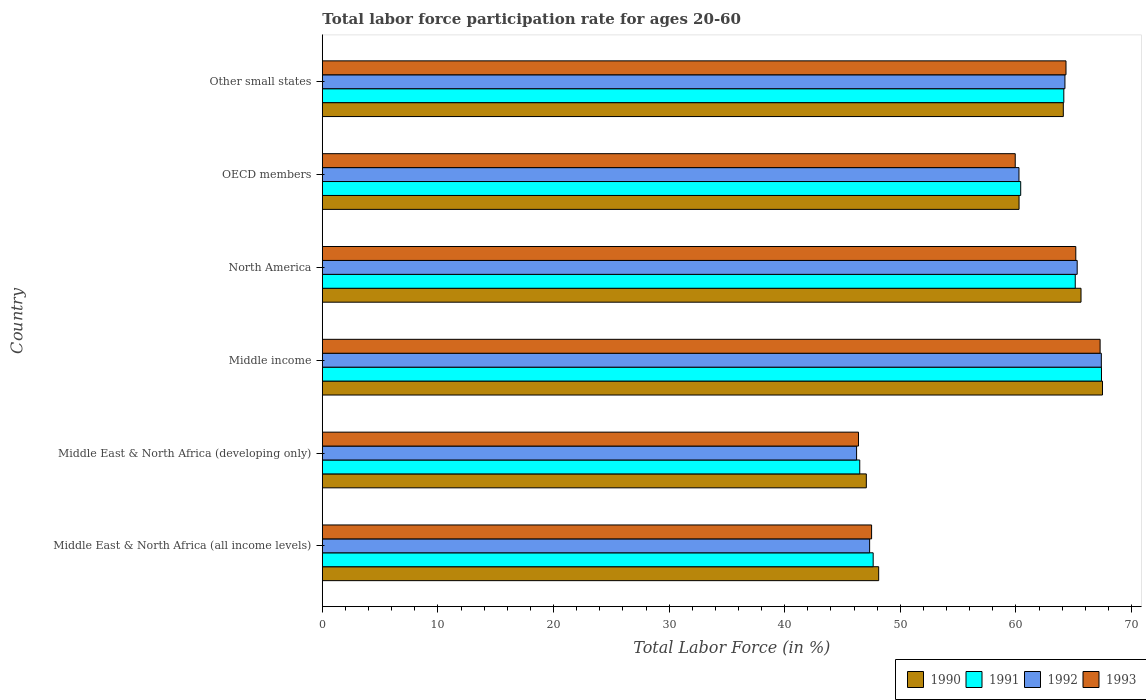How many bars are there on the 3rd tick from the bottom?
Ensure brevity in your answer.  4. What is the labor force participation rate in 1992 in Middle income?
Your response must be concise. 67.39. Across all countries, what is the maximum labor force participation rate in 1993?
Keep it short and to the point. 67.28. Across all countries, what is the minimum labor force participation rate in 1990?
Make the answer very short. 47.06. In which country was the labor force participation rate in 1993 maximum?
Provide a short and direct response. Middle income. In which country was the labor force participation rate in 1992 minimum?
Provide a succinct answer. Middle East & North Africa (developing only). What is the total labor force participation rate in 1993 in the graph?
Your response must be concise. 350.63. What is the difference between the labor force participation rate in 1993 in Middle East & North Africa (developing only) and that in OECD members?
Give a very brief answer. -13.56. What is the difference between the labor force participation rate in 1991 in OECD members and the labor force participation rate in 1990 in North America?
Ensure brevity in your answer.  -5.22. What is the average labor force participation rate in 1992 per country?
Your answer should be compact. 58.46. What is the difference between the labor force participation rate in 1992 and labor force participation rate in 1990 in North America?
Your answer should be very brief. -0.33. What is the ratio of the labor force participation rate in 1993 in Middle East & North Africa (developing only) to that in Middle income?
Give a very brief answer. 0.69. Is the difference between the labor force participation rate in 1992 in OECD members and Other small states greater than the difference between the labor force participation rate in 1990 in OECD members and Other small states?
Provide a short and direct response. No. What is the difference between the highest and the second highest labor force participation rate in 1990?
Keep it short and to the point. 1.86. What is the difference between the highest and the lowest labor force participation rate in 1992?
Provide a succinct answer. 21.17. In how many countries, is the labor force participation rate in 1990 greater than the average labor force participation rate in 1990 taken over all countries?
Ensure brevity in your answer.  4. What does the 4th bar from the bottom in Middle East & North Africa (all income levels) represents?
Make the answer very short. 1993. Is it the case that in every country, the sum of the labor force participation rate in 1993 and labor force participation rate in 1990 is greater than the labor force participation rate in 1991?
Make the answer very short. Yes. How many bars are there?
Make the answer very short. 24. Are all the bars in the graph horizontal?
Your answer should be compact. Yes. Are the values on the major ticks of X-axis written in scientific E-notation?
Provide a short and direct response. No. Where does the legend appear in the graph?
Your answer should be very brief. Bottom right. How are the legend labels stacked?
Your answer should be compact. Horizontal. What is the title of the graph?
Make the answer very short. Total labor force participation rate for ages 20-60. What is the label or title of the Y-axis?
Offer a very short reply. Country. What is the Total Labor Force (in %) of 1990 in Middle East & North Africa (all income levels)?
Keep it short and to the point. 48.13. What is the Total Labor Force (in %) in 1991 in Middle East & North Africa (all income levels)?
Provide a succinct answer. 47.65. What is the Total Labor Force (in %) in 1992 in Middle East & North Africa (all income levels)?
Offer a terse response. 47.34. What is the Total Labor Force (in %) of 1993 in Middle East & North Africa (all income levels)?
Your response must be concise. 47.51. What is the Total Labor Force (in %) in 1990 in Middle East & North Africa (developing only)?
Your response must be concise. 47.06. What is the Total Labor Force (in %) of 1991 in Middle East & North Africa (developing only)?
Give a very brief answer. 46.49. What is the Total Labor Force (in %) in 1992 in Middle East & North Africa (developing only)?
Give a very brief answer. 46.22. What is the Total Labor Force (in %) of 1993 in Middle East & North Africa (developing only)?
Your answer should be very brief. 46.38. What is the Total Labor Force (in %) of 1990 in Middle income?
Your response must be concise. 67.49. What is the Total Labor Force (in %) in 1991 in Middle income?
Provide a short and direct response. 67.4. What is the Total Labor Force (in %) of 1992 in Middle income?
Ensure brevity in your answer.  67.39. What is the Total Labor Force (in %) of 1993 in Middle income?
Keep it short and to the point. 67.28. What is the Total Labor Force (in %) of 1990 in North America?
Provide a succinct answer. 65.63. What is the Total Labor Force (in %) of 1991 in North America?
Your answer should be compact. 65.13. What is the Total Labor Force (in %) of 1992 in North America?
Provide a short and direct response. 65.3. What is the Total Labor Force (in %) of 1993 in North America?
Offer a terse response. 65.18. What is the Total Labor Force (in %) of 1990 in OECD members?
Provide a succinct answer. 60.27. What is the Total Labor Force (in %) of 1991 in OECD members?
Your answer should be compact. 60.41. What is the Total Labor Force (in %) of 1992 in OECD members?
Your answer should be compact. 60.26. What is the Total Labor Force (in %) in 1993 in OECD members?
Keep it short and to the point. 59.94. What is the Total Labor Force (in %) in 1990 in Other small states?
Make the answer very short. 64.1. What is the Total Labor Force (in %) in 1991 in Other small states?
Your response must be concise. 64.14. What is the Total Labor Force (in %) of 1992 in Other small states?
Keep it short and to the point. 64.24. What is the Total Labor Force (in %) of 1993 in Other small states?
Provide a succinct answer. 64.33. Across all countries, what is the maximum Total Labor Force (in %) of 1990?
Offer a terse response. 67.49. Across all countries, what is the maximum Total Labor Force (in %) of 1991?
Provide a succinct answer. 67.4. Across all countries, what is the maximum Total Labor Force (in %) in 1992?
Your response must be concise. 67.39. Across all countries, what is the maximum Total Labor Force (in %) in 1993?
Offer a terse response. 67.28. Across all countries, what is the minimum Total Labor Force (in %) in 1990?
Give a very brief answer. 47.06. Across all countries, what is the minimum Total Labor Force (in %) of 1991?
Your answer should be compact. 46.49. Across all countries, what is the minimum Total Labor Force (in %) of 1992?
Keep it short and to the point. 46.22. Across all countries, what is the minimum Total Labor Force (in %) in 1993?
Offer a very short reply. 46.38. What is the total Total Labor Force (in %) of 1990 in the graph?
Your answer should be compact. 352.67. What is the total Total Labor Force (in %) of 1991 in the graph?
Keep it short and to the point. 351.23. What is the total Total Labor Force (in %) in 1992 in the graph?
Keep it short and to the point. 350.75. What is the total Total Labor Force (in %) of 1993 in the graph?
Provide a succinct answer. 350.63. What is the difference between the Total Labor Force (in %) of 1990 in Middle East & North Africa (all income levels) and that in Middle East & North Africa (developing only)?
Give a very brief answer. 1.07. What is the difference between the Total Labor Force (in %) of 1991 in Middle East & North Africa (all income levels) and that in Middle East & North Africa (developing only)?
Make the answer very short. 1.16. What is the difference between the Total Labor Force (in %) of 1992 in Middle East & North Africa (all income levels) and that in Middle East & North Africa (developing only)?
Your response must be concise. 1.13. What is the difference between the Total Labor Force (in %) in 1993 in Middle East & North Africa (all income levels) and that in Middle East & North Africa (developing only)?
Make the answer very short. 1.13. What is the difference between the Total Labor Force (in %) in 1990 in Middle East & North Africa (all income levels) and that in Middle income?
Make the answer very short. -19.36. What is the difference between the Total Labor Force (in %) in 1991 in Middle East & North Africa (all income levels) and that in Middle income?
Provide a short and direct response. -19.75. What is the difference between the Total Labor Force (in %) in 1992 in Middle East & North Africa (all income levels) and that in Middle income?
Your response must be concise. -20.04. What is the difference between the Total Labor Force (in %) in 1993 in Middle East & North Africa (all income levels) and that in Middle income?
Your response must be concise. -19.77. What is the difference between the Total Labor Force (in %) of 1990 in Middle East & North Africa (all income levels) and that in North America?
Your answer should be compact. -17.51. What is the difference between the Total Labor Force (in %) of 1991 in Middle East & North Africa (all income levels) and that in North America?
Make the answer very short. -17.48. What is the difference between the Total Labor Force (in %) in 1992 in Middle East & North Africa (all income levels) and that in North America?
Offer a terse response. -17.96. What is the difference between the Total Labor Force (in %) of 1993 in Middle East & North Africa (all income levels) and that in North America?
Your answer should be compact. -17.66. What is the difference between the Total Labor Force (in %) in 1990 in Middle East & North Africa (all income levels) and that in OECD members?
Provide a short and direct response. -12.14. What is the difference between the Total Labor Force (in %) in 1991 in Middle East & North Africa (all income levels) and that in OECD members?
Make the answer very short. -12.76. What is the difference between the Total Labor Force (in %) in 1992 in Middle East & North Africa (all income levels) and that in OECD members?
Keep it short and to the point. -12.92. What is the difference between the Total Labor Force (in %) of 1993 in Middle East & North Africa (all income levels) and that in OECD members?
Ensure brevity in your answer.  -12.43. What is the difference between the Total Labor Force (in %) in 1990 in Middle East & North Africa (all income levels) and that in Other small states?
Your response must be concise. -15.97. What is the difference between the Total Labor Force (in %) in 1991 in Middle East & North Africa (all income levels) and that in Other small states?
Offer a very short reply. -16.49. What is the difference between the Total Labor Force (in %) in 1992 in Middle East & North Africa (all income levels) and that in Other small states?
Your response must be concise. -16.9. What is the difference between the Total Labor Force (in %) in 1993 in Middle East & North Africa (all income levels) and that in Other small states?
Make the answer very short. -16.82. What is the difference between the Total Labor Force (in %) in 1990 in Middle East & North Africa (developing only) and that in Middle income?
Your answer should be very brief. -20.43. What is the difference between the Total Labor Force (in %) of 1991 in Middle East & North Africa (developing only) and that in Middle income?
Ensure brevity in your answer.  -20.91. What is the difference between the Total Labor Force (in %) of 1992 in Middle East & North Africa (developing only) and that in Middle income?
Ensure brevity in your answer.  -21.17. What is the difference between the Total Labor Force (in %) in 1993 in Middle East & North Africa (developing only) and that in Middle income?
Provide a succinct answer. -20.9. What is the difference between the Total Labor Force (in %) of 1990 in Middle East & North Africa (developing only) and that in North America?
Your answer should be compact. -18.57. What is the difference between the Total Labor Force (in %) in 1991 in Middle East & North Africa (developing only) and that in North America?
Give a very brief answer. -18.64. What is the difference between the Total Labor Force (in %) of 1992 in Middle East & North Africa (developing only) and that in North America?
Offer a very short reply. -19.08. What is the difference between the Total Labor Force (in %) of 1993 in Middle East & North Africa (developing only) and that in North America?
Keep it short and to the point. -18.8. What is the difference between the Total Labor Force (in %) of 1990 in Middle East & North Africa (developing only) and that in OECD members?
Offer a very short reply. -13.21. What is the difference between the Total Labor Force (in %) of 1991 in Middle East & North Africa (developing only) and that in OECD members?
Offer a very short reply. -13.92. What is the difference between the Total Labor Force (in %) in 1992 in Middle East & North Africa (developing only) and that in OECD members?
Your answer should be very brief. -14.05. What is the difference between the Total Labor Force (in %) of 1993 in Middle East & North Africa (developing only) and that in OECD members?
Keep it short and to the point. -13.56. What is the difference between the Total Labor Force (in %) in 1990 in Middle East & North Africa (developing only) and that in Other small states?
Give a very brief answer. -17.04. What is the difference between the Total Labor Force (in %) of 1991 in Middle East & North Africa (developing only) and that in Other small states?
Keep it short and to the point. -17.65. What is the difference between the Total Labor Force (in %) in 1992 in Middle East & North Africa (developing only) and that in Other small states?
Provide a succinct answer. -18.02. What is the difference between the Total Labor Force (in %) in 1993 in Middle East & North Africa (developing only) and that in Other small states?
Your answer should be very brief. -17.95. What is the difference between the Total Labor Force (in %) in 1990 in Middle income and that in North America?
Ensure brevity in your answer.  1.86. What is the difference between the Total Labor Force (in %) of 1991 in Middle income and that in North America?
Offer a very short reply. 2.27. What is the difference between the Total Labor Force (in %) in 1992 in Middle income and that in North America?
Provide a succinct answer. 2.09. What is the difference between the Total Labor Force (in %) of 1993 in Middle income and that in North America?
Offer a very short reply. 2.1. What is the difference between the Total Labor Force (in %) in 1990 in Middle income and that in OECD members?
Ensure brevity in your answer.  7.22. What is the difference between the Total Labor Force (in %) of 1991 in Middle income and that in OECD members?
Your answer should be compact. 6.99. What is the difference between the Total Labor Force (in %) in 1992 in Middle income and that in OECD members?
Your answer should be very brief. 7.12. What is the difference between the Total Labor Force (in %) in 1993 in Middle income and that in OECD members?
Offer a terse response. 7.34. What is the difference between the Total Labor Force (in %) of 1990 in Middle income and that in Other small states?
Provide a succinct answer. 3.39. What is the difference between the Total Labor Force (in %) of 1991 in Middle income and that in Other small states?
Your response must be concise. 3.26. What is the difference between the Total Labor Force (in %) of 1992 in Middle income and that in Other small states?
Offer a terse response. 3.15. What is the difference between the Total Labor Force (in %) of 1993 in Middle income and that in Other small states?
Give a very brief answer. 2.95. What is the difference between the Total Labor Force (in %) of 1990 in North America and that in OECD members?
Provide a short and direct response. 5.36. What is the difference between the Total Labor Force (in %) of 1991 in North America and that in OECD members?
Your response must be concise. 4.72. What is the difference between the Total Labor Force (in %) in 1992 in North America and that in OECD members?
Offer a very short reply. 5.04. What is the difference between the Total Labor Force (in %) of 1993 in North America and that in OECD members?
Your answer should be very brief. 5.24. What is the difference between the Total Labor Force (in %) in 1990 in North America and that in Other small states?
Offer a very short reply. 1.53. What is the difference between the Total Labor Force (in %) of 1991 in North America and that in Other small states?
Provide a succinct answer. 0.99. What is the difference between the Total Labor Force (in %) of 1992 in North America and that in Other small states?
Your answer should be compact. 1.06. What is the difference between the Total Labor Force (in %) in 1993 in North America and that in Other small states?
Your answer should be compact. 0.85. What is the difference between the Total Labor Force (in %) in 1990 in OECD members and that in Other small states?
Keep it short and to the point. -3.83. What is the difference between the Total Labor Force (in %) in 1991 in OECD members and that in Other small states?
Your answer should be compact. -3.73. What is the difference between the Total Labor Force (in %) in 1992 in OECD members and that in Other small states?
Ensure brevity in your answer.  -3.98. What is the difference between the Total Labor Force (in %) of 1993 in OECD members and that in Other small states?
Give a very brief answer. -4.39. What is the difference between the Total Labor Force (in %) in 1990 in Middle East & North Africa (all income levels) and the Total Labor Force (in %) in 1991 in Middle East & North Africa (developing only)?
Ensure brevity in your answer.  1.64. What is the difference between the Total Labor Force (in %) in 1990 in Middle East & North Africa (all income levels) and the Total Labor Force (in %) in 1992 in Middle East & North Africa (developing only)?
Make the answer very short. 1.91. What is the difference between the Total Labor Force (in %) of 1990 in Middle East & North Africa (all income levels) and the Total Labor Force (in %) of 1993 in Middle East & North Africa (developing only)?
Make the answer very short. 1.75. What is the difference between the Total Labor Force (in %) of 1991 in Middle East & North Africa (all income levels) and the Total Labor Force (in %) of 1992 in Middle East & North Africa (developing only)?
Offer a terse response. 1.43. What is the difference between the Total Labor Force (in %) of 1991 in Middle East & North Africa (all income levels) and the Total Labor Force (in %) of 1993 in Middle East & North Africa (developing only)?
Your response must be concise. 1.27. What is the difference between the Total Labor Force (in %) in 1992 in Middle East & North Africa (all income levels) and the Total Labor Force (in %) in 1993 in Middle East & North Africa (developing only)?
Give a very brief answer. 0.96. What is the difference between the Total Labor Force (in %) of 1990 in Middle East & North Africa (all income levels) and the Total Labor Force (in %) of 1991 in Middle income?
Give a very brief answer. -19.28. What is the difference between the Total Labor Force (in %) in 1990 in Middle East & North Africa (all income levels) and the Total Labor Force (in %) in 1992 in Middle income?
Make the answer very short. -19.26. What is the difference between the Total Labor Force (in %) of 1990 in Middle East & North Africa (all income levels) and the Total Labor Force (in %) of 1993 in Middle income?
Provide a short and direct response. -19.16. What is the difference between the Total Labor Force (in %) of 1991 in Middle East & North Africa (all income levels) and the Total Labor Force (in %) of 1992 in Middle income?
Offer a very short reply. -19.74. What is the difference between the Total Labor Force (in %) in 1991 in Middle East & North Africa (all income levels) and the Total Labor Force (in %) in 1993 in Middle income?
Your answer should be very brief. -19.63. What is the difference between the Total Labor Force (in %) of 1992 in Middle East & North Africa (all income levels) and the Total Labor Force (in %) of 1993 in Middle income?
Ensure brevity in your answer.  -19.94. What is the difference between the Total Labor Force (in %) in 1990 in Middle East & North Africa (all income levels) and the Total Labor Force (in %) in 1991 in North America?
Keep it short and to the point. -17.01. What is the difference between the Total Labor Force (in %) of 1990 in Middle East & North Africa (all income levels) and the Total Labor Force (in %) of 1992 in North America?
Make the answer very short. -17.17. What is the difference between the Total Labor Force (in %) in 1990 in Middle East & North Africa (all income levels) and the Total Labor Force (in %) in 1993 in North America?
Make the answer very short. -17.05. What is the difference between the Total Labor Force (in %) in 1991 in Middle East & North Africa (all income levels) and the Total Labor Force (in %) in 1992 in North America?
Keep it short and to the point. -17.65. What is the difference between the Total Labor Force (in %) of 1991 in Middle East & North Africa (all income levels) and the Total Labor Force (in %) of 1993 in North America?
Offer a very short reply. -17.53. What is the difference between the Total Labor Force (in %) of 1992 in Middle East & North Africa (all income levels) and the Total Labor Force (in %) of 1993 in North America?
Your answer should be compact. -17.84. What is the difference between the Total Labor Force (in %) of 1990 in Middle East & North Africa (all income levels) and the Total Labor Force (in %) of 1991 in OECD members?
Offer a terse response. -12.29. What is the difference between the Total Labor Force (in %) in 1990 in Middle East & North Africa (all income levels) and the Total Labor Force (in %) in 1992 in OECD members?
Your answer should be compact. -12.14. What is the difference between the Total Labor Force (in %) of 1990 in Middle East & North Africa (all income levels) and the Total Labor Force (in %) of 1993 in OECD members?
Provide a succinct answer. -11.81. What is the difference between the Total Labor Force (in %) of 1991 in Middle East & North Africa (all income levels) and the Total Labor Force (in %) of 1992 in OECD members?
Keep it short and to the point. -12.61. What is the difference between the Total Labor Force (in %) in 1991 in Middle East & North Africa (all income levels) and the Total Labor Force (in %) in 1993 in OECD members?
Your response must be concise. -12.29. What is the difference between the Total Labor Force (in %) in 1992 in Middle East & North Africa (all income levels) and the Total Labor Force (in %) in 1993 in OECD members?
Offer a very short reply. -12.6. What is the difference between the Total Labor Force (in %) in 1990 in Middle East & North Africa (all income levels) and the Total Labor Force (in %) in 1991 in Other small states?
Your answer should be very brief. -16.02. What is the difference between the Total Labor Force (in %) of 1990 in Middle East & North Africa (all income levels) and the Total Labor Force (in %) of 1992 in Other small states?
Make the answer very short. -16.11. What is the difference between the Total Labor Force (in %) of 1990 in Middle East & North Africa (all income levels) and the Total Labor Force (in %) of 1993 in Other small states?
Your answer should be compact. -16.21. What is the difference between the Total Labor Force (in %) of 1991 in Middle East & North Africa (all income levels) and the Total Labor Force (in %) of 1992 in Other small states?
Provide a succinct answer. -16.59. What is the difference between the Total Labor Force (in %) in 1991 in Middle East & North Africa (all income levels) and the Total Labor Force (in %) in 1993 in Other small states?
Provide a succinct answer. -16.68. What is the difference between the Total Labor Force (in %) of 1992 in Middle East & North Africa (all income levels) and the Total Labor Force (in %) of 1993 in Other small states?
Make the answer very short. -16.99. What is the difference between the Total Labor Force (in %) of 1990 in Middle East & North Africa (developing only) and the Total Labor Force (in %) of 1991 in Middle income?
Offer a terse response. -20.34. What is the difference between the Total Labor Force (in %) of 1990 in Middle East & North Africa (developing only) and the Total Labor Force (in %) of 1992 in Middle income?
Offer a very short reply. -20.33. What is the difference between the Total Labor Force (in %) of 1990 in Middle East & North Africa (developing only) and the Total Labor Force (in %) of 1993 in Middle income?
Provide a succinct answer. -20.22. What is the difference between the Total Labor Force (in %) in 1991 in Middle East & North Africa (developing only) and the Total Labor Force (in %) in 1992 in Middle income?
Offer a terse response. -20.9. What is the difference between the Total Labor Force (in %) in 1991 in Middle East & North Africa (developing only) and the Total Labor Force (in %) in 1993 in Middle income?
Provide a succinct answer. -20.79. What is the difference between the Total Labor Force (in %) in 1992 in Middle East & North Africa (developing only) and the Total Labor Force (in %) in 1993 in Middle income?
Offer a terse response. -21.07. What is the difference between the Total Labor Force (in %) of 1990 in Middle East & North Africa (developing only) and the Total Labor Force (in %) of 1991 in North America?
Offer a terse response. -18.07. What is the difference between the Total Labor Force (in %) in 1990 in Middle East & North Africa (developing only) and the Total Labor Force (in %) in 1992 in North America?
Provide a succinct answer. -18.24. What is the difference between the Total Labor Force (in %) in 1990 in Middle East & North Africa (developing only) and the Total Labor Force (in %) in 1993 in North America?
Offer a very short reply. -18.12. What is the difference between the Total Labor Force (in %) in 1991 in Middle East & North Africa (developing only) and the Total Labor Force (in %) in 1992 in North America?
Provide a short and direct response. -18.81. What is the difference between the Total Labor Force (in %) of 1991 in Middle East & North Africa (developing only) and the Total Labor Force (in %) of 1993 in North America?
Ensure brevity in your answer.  -18.69. What is the difference between the Total Labor Force (in %) in 1992 in Middle East & North Africa (developing only) and the Total Labor Force (in %) in 1993 in North America?
Make the answer very short. -18.96. What is the difference between the Total Labor Force (in %) of 1990 in Middle East & North Africa (developing only) and the Total Labor Force (in %) of 1991 in OECD members?
Your answer should be compact. -13.35. What is the difference between the Total Labor Force (in %) in 1990 in Middle East & North Africa (developing only) and the Total Labor Force (in %) in 1992 in OECD members?
Offer a terse response. -13.21. What is the difference between the Total Labor Force (in %) of 1990 in Middle East & North Africa (developing only) and the Total Labor Force (in %) of 1993 in OECD members?
Keep it short and to the point. -12.88. What is the difference between the Total Labor Force (in %) in 1991 in Middle East & North Africa (developing only) and the Total Labor Force (in %) in 1992 in OECD members?
Ensure brevity in your answer.  -13.77. What is the difference between the Total Labor Force (in %) of 1991 in Middle East & North Africa (developing only) and the Total Labor Force (in %) of 1993 in OECD members?
Ensure brevity in your answer.  -13.45. What is the difference between the Total Labor Force (in %) of 1992 in Middle East & North Africa (developing only) and the Total Labor Force (in %) of 1993 in OECD members?
Your answer should be very brief. -13.72. What is the difference between the Total Labor Force (in %) in 1990 in Middle East & North Africa (developing only) and the Total Labor Force (in %) in 1991 in Other small states?
Make the answer very short. -17.08. What is the difference between the Total Labor Force (in %) of 1990 in Middle East & North Africa (developing only) and the Total Labor Force (in %) of 1992 in Other small states?
Your answer should be compact. -17.18. What is the difference between the Total Labor Force (in %) in 1990 in Middle East & North Africa (developing only) and the Total Labor Force (in %) in 1993 in Other small states?
Offer a very short reply. -17.27. What is the difference between the Total Labor Force (in %) of 1991 in Middle East & North Africa (developing only) and the Total Labor Force (in %) of 1992 in Other small states?
Your answer should be very brief. -17.75. What is the difference between the Total Labor Force (in %) in 1991 in Middle East & North Africa (developing only) and the Total Labor Force (in %) in 1993 in Other small states?
Your answer should be very brief. -17.84. What is the difference between the Total Labor Force (in %) of 1992 in Middle East & North Africa (developing only) and the Total Labor Force (in %) of 1993 in Other small states?
Offer a terse response. -18.11. What is the difference between the Total Labor Force (in %) in 1990 in Middle income and the Total Labor Force (in %) in 1991 in North America?
Offer a very short reply. 2.36. What is the difference between the Total Labor Force (in %) of 1990 in Middle income and the Total Labor Force (in %) of 1992 in North America?
Your response must be concise. 2.19. What is the difference between the Total Labor Force (in %) of 1990 in Middle income and the Total Labor Force (in %) of 1993 in North America?
Give a very brief answer. 2.31. What is the difference between the Total Labor Force (in %) of 1991 in Middle income and the Total Labor Force (in %) of 1992 in North America?
Your response must be concise. 2.1. What is the difference between the Total Labor Force (in %) of 1991 in Middle income and the Total Labor Force (in %) of 1993 in North America?
Give a very brief answer. 2.22. What is the difference between the Total Labor Force (in %) in 1992 in Middle income and the Total Labor Force (in %) in 1993 in North America?
Give a very brief answer. 2.21. What is the difference between the Total Labor Force (in %) in 1990 in Middle income and the Total Labor Force (in %) in 1991 in OECD members?
Give a very brief answer. 7.07. What is the difference between the Total Labor Force (in %) of 1990 in Middle income and the Total Labor Force (in %) of 1992 in OECD members?
Offer a very short reply. 7.22. What is the difference between the Total Labor Force (in %) of 1990 in Middle income and the Total Labor Force (in %) of 1993 in OECD members?
Offer a very short reply. 7.55. What is the difference between the Total Labor Force (in %) of 1991 in Middle income and the Total Labor Force (in %) of 1992 in OECD members?
Make the answer very short. 7.14. What is the difference between the Total Labor Force (in %) of 1991 in Middle income and the Total Labor Force (in %) of 1993 in OECD members?
Provide a short and direct response. 7.46. What is the difference between the Total Labor Force (in %) in 1992 in Middle income and the Total Labor Force (in %) in 1993 in OECD members?
Provide a short and direct response. 7.45. What is the difference between the Total Labor Force (in %) in 1990 in Middle income and the Total Labor Force (in %) in 1991 in Other small states?
Keep it short and to the point. 3.34. What is the difference between the Total Labor Force (in %) in 1990 in Middle income and the Total Labor Force (in %) in 1992 in Other small states?
Ensure brevity in your answer.  3.25. What is the difference between the Total Labor Force (in %) of 1990 in Middle income and the Total Labor Force (in %) of 1993 in Other small states?
Make the answer very short. 3.16. What is the difference between the Total Labor Force (in %) of 1991 in Middle income and the Total Labor Force (in %) of 1992 in Other small states?
Offer a very short reply. 3.16. What is the difference between the Total Labor Force (in %) of 1991 in Middle income and the Total Labor Force (in %) of 1993 in Other small states?
Provide a short and direct response. 3.07. What is the difference between the Total Labor Force (in %) of 1992 in Middle income and the Total Labor Force (in %) of 1993 in Other small states?
Ensure brevity in your answer.  3.06. What is the difference between the Total Labor Force (in %) in 1990 in North America and the Total Labor Force (in %) in 1991 in OECD members?
Offer a terse response. 5.22. What is the difference between the Total Labor Force (in %) in 1990 in North America and the Total Labor Force (in %) in 1992 in OECD members?
Offer a terse response. 5.37. What is the difference between the Total Labor Force (in %) in 1990 in North America and the Total Labor Force (in %) in 1993 in OECD members?
Ensure brevity in your answer.  5.69. What is the difference between the Total Labor Force (in %) of 1991 in North America and the Total Labor Force (in %) of 1992 in OECD members?
Offer a terse response. 4.87. What is the difference between the Total Labor Force (in %) of 1991 in North America and the Total Labor Force (in %) of 1993 in OECD members?
Your answer should be very brief. 5.19. What is the difference between the Total Labor Force (in %) of 1992 in North America and the Total Labor Force (in %) of 1993 in OECD members?
Provide a short and direct response. 5.36. What is the difference between the Total Labor Force (in %) in 1990 in North America and the Total Labor Force (in %) in 1991 in Other small states?
Make the answer very short. 1.49. What is the difference between the Total Labor Force (in %) in 1990 in North America and the Total Labor Force (in %) in 1992 in Other small states?
Keep it short and to the point. 1.39. What is the difference between the Total Labor Force (in %) in 1990 in North America and the Total Labor Force (in %) in 1993 in Other small states?
Your answer should be compact. 1.3. What is the difference between the Total Labor Force (in %) in 1991 in North America and the Total Labor Force (in %) in 1992 in Other small states?
Your response must be concise. 0.89. What is the difference between the Total Labor Force (in %) of 1991 in North America and the Total Labor Force (in %) of 1993 in Other small states?
Ensure brevity in your answer.  0.8. What is the difference between the Total Labor Force (in %) in 1992 in North America and the Total Labor Force (in %) in 1993 in Other small states?
Provide a succinct answer. 0.97. What is the difference between the Total Labor Force (in %) in 1990 in OECD members and the Total Labor Force (in %) in 1991 in Other small states?
Make the answer very short. -3.87. What is the difference between the Total Labor Force (in %) of 1990 in OECD members and the Total Labor Force (in %) of 1992 in Other small states?
Your answer should be very brief. -3.97. What is the difference between the Total Labor Force (in %) of 1990 in OECD members and the Total Labor Force (in %) of 1993 in Other small states?
Keep it short and to the point. -4.06. What is the difference between the Total Labor Force (in %) in 1991 in OECD members and the Total Labor Force (in %) in 1992 in Other small states?
Make the answer very short. -3.83. What is the difference between the Total Labor Force (in %) of 1991 in OECD members and the Total Labor Force (in %) of 1993 in Other small states?
Your answer should be very brief. -3.92. What is the difference between the Total Labor Force (in %) in 1992 in OECD members and the Total Labor Force (in %) in 1993 in Other small states?
Your answer should be very brief. -4.07. What is the average Total Labor Force (in %) of 1990 per country?
Give a very brief answer. 58.78. What is the average Total Labor Force (in %) of 1991 per country?
Offer a very short reply. 58.54. What is the average Total Labor Force (in %) in 1992 per country?
Your response must be concise. 58.46. What is the average Total Labor Force (in %) in 1993 per country?
Offer a very short reply. 58.44. What is the difference between the Total Labor Force (in %) of 1990 and Total Labor Force (in %) of 1991 in Middle East & North Africa (all income levels)?
Provide a succinct answer. 0.48. What is the difference between the Total Labor Force (in %) of 1990 and Total Labor Force (in %) of 1992 in Middle East & North Africa (all income levels)?
Your answer should be very brief. 0.78. What is the difference between the Total Labor Force (in %) of 1990 and Total Labor Force (in %) of 1993 in Middle East & North Africa (all income levels)?
Offer a very short reply. 0.61. What is the difference between the Total Labor Force (in %) of 1991 and Total Labor Force (in %) of 1992 in Middle East & North Africa (all income levels)?
Make the answer very short. 0.31. What is the difference between the Total Labor Force (in %) in 1991 and Total Labor Force (in %) in 1993 in Middle East & North Africa (all income levels)?
Provide a short and direct response. 0.14. What is the difference between the Total Labor Force (in %) in 1992 and Total Labor Force (in %) in 1993 in Middle East & North Africa (all income levels)?
Make the answer very short. -0.17. What is the difference between the Total Labor Force (in %) of 1990 and Total Labor Force (in %) of 1991 in Middle East & North Africa (developing only)?
Provide a succinct answer. 0.57. What is the difference between the Total Labor Force (in %) in 1990 and Total Labor Force (in %) in 1992 in Middle East & North Africa (developing only)?
Offer a terse response. 0.84. What is the difference between the Total Labor Force (in %) in 1990 and Total Labor Force (in %) in 1993 in Middle East & North Africa (developing only)?
Provide a succinct answer. 0.68. What is the difference between the Total Labor Force (in %) in 1991 and Total Labor Force (in %) in 1992 in Middle East & North Africa (developing only)?
Your response must be concise. 0.27. What is the difference between the Total Labor Force (in %) in 1991 and Total Labor Force (in %) in 1993 in Middle East & North Africa (developing only)?
Make the answer very short. 0.11. What is the difference between the Total Labor Force (in %) in 1992 and Total Labor Force (in %) in 1993 in Middle East & North Africa (developing only)?
Your answer should be very brief. -0.16. What is the difference between the Total Labor Force (in %) of 1990 and Total Labor Force (in %) of 1991 in Middle income?
Provide a short and direct response. 0.09. What is the difference between the Total Labor Force (in %) in 1990 and Total Labor Force (in %) in 1992 in Middle income?
Offer a very short reply. 0.1. What is the difference between the Total Labor Force (in %) of 1990 and Total Labor Force (in %) of 1993 in Middle income?
Offer a very short reply. 0.2. What is the difference between the Total Labor Force (in %) in 1991 and Total Labor Force (in %) in 1992 in Middle income?
Your answer should be compact. 0.01. What is the difference between the Total Labor Force (in %) of 1991 and Total Labor Force (in %) of 1993 in Middle income?
Ensure brevity in your answer.  0.12. What is the difference between the Total Labor Force (in %) in 1992 and Total Labor Force (in %) in 1993 in Middle income?
Offer a terse response. 0.1. What is the difference between the Total Labor Force (in %) in 1990 and Total Labor Force (in %) in 1991 in North America?
Make the answer very short. 0.5. What is the difference between the Total Labor Force (in %) of 1990 and Total Labor Force (in %) of 1992 in North America?
Your response must be concise. 0.33. What is the difference between the Total Labor Force (in %) in 1990 and Total Labor Force (in %) in 1993 in North America?
Provide a succinct answer. 0.45. What is the difference between the Total Labor Force (in %) of 1991 and Total Labor Force (in %) of 1992 in North America?
Your answer should be very brief. -0.17. What is the difference between the Total Labor Force (in %) in 1991 and Total Labor Force (in %) in 1993 in North America?
Provide a succinct answer. -0.05. What is the difference between the Total Labor Force (in %) in 1992 and Total Labor Force (in %) in 1993 in North America?
Provide a succinct answer. 0.12. What is the difference between the Total Labor Force (in %) of 1990 and Total Labor Force (in %) of 1991 in OECD members?
Ensure brevity in your answer.  -0.14. What is the difference between the Total Labor Force (in %) in 1990 and Total Labor Force (in %) in 1992 in OECD members?
Provide a succinct answer. 0.01. What is the difference between the Total Labor Force (in %) of 1990 and Total Labor Force (in %) of 1993 in OECD members?
Make the answer very short. 0.33. What is the difference between the Total Labor Force (in %) of 1991 and Total Labor Force (in %) of 1992 in OECD members?
Your response must be concise. 0.15. What is the difference between the Total Labor Force (in %) of 1991 and Total Labor Force (in %) of 1993 in OECD members?
Offer a very short reply. 0.47. What is the difference between the Total Labor Force (in %) of 1992 and Total Labor Force (in %) of 1993 in OECD members?
Your answer should be very brief. 0.32. What is the difference between the Total Labor Force (in %) in 1990 and Total Labor Force (in %) in 1991 in Other small states?
Make the answer very short. -0.04. What is the difference between the Total Labor Force (in %) of 1990 and Total Labor Force (in %) of 1992 in Other small states?
Your answer should be very brief. -0.14. What is the difference between the Total Labor Force (in %) of 1990 and Total Labor Force (in %) of 1993 in Other small states?
Your answer should be compact. -0.23. What is the difference between the Total Labor Force (in %) in 1991 and Total Labor Force (in %) in 1992 in Other small states?
Make the answer very short. -0.1. What is the difference between the Total Labor Force (in %) of 1991 and Total Labor Force (in %) of 1993 in Other small states?
Your answer should be very brief. -0.19. What is the difference between the Total Labor Force (in %) of 1992 and Total Labor Force (in %) of 1993 in Other small states?
Ensure brevity in your answer.  -0.09. What is the ratio of the Total Labor Force (in %) in 1990 in Middle East & North Africa (all income levels) to that in Middle East & North Africa (developing only)?
Provide a succinct answer. 1.02. What is the ratio of the Total Labor Force (in %) in 1992 in Middle East & North Africa (all income levels) to that in Middle East & North Africa (developing only)?
Make the answer very short. 1.02. What is the ratio of the Total Labor Force (in %) of 1993 in Middle East & North Africa (all income levels) to that in Middle East & North Africa (developing only)?
Provide a short and direct response. 1.02. What is the ratio of the Total Labor Force (in %) in 1990 in Middle East & North Africa (all income levels) to that in Middle income?
Provide a short and direct response. 0.71. What is the ratio of the Total Labor Force (in %) in 1991 in Middle East & North Africa (all income levels) to that in Middle income?
Your response must be concise. 0.71. What is the ratio of the Total Labor Force (in %) of 1992 in Middle East & North Africa (all income levels) to that in Middle income?
Ensure brevity in your answer.  0.7. What is the ratio of the Total Labor Force (in %) of 1993 in Middle East & North Africa (all income levels) to that in Middle income?
Offer a terse response. 0.71. What is the ratio of the Total Labor Force (in %) in 1990 in Middle East & North Africa (all income levels) to that in North America?
Keep it short and to the point. 0.73. What is the ratio of the Total Labor Force (in %) of 1991 in Middle East & North Africa (all income levels) to that in North America?
Your answer should be compact. 0.73. What is the ratio of the Total Labor Force (in %) in 1992 in Middle East & North Africa (all income levels) to that in North America?
Ensure brevity in your answer.  0.72. What is the ratio of the Total Labor Force (in %) of 1993 in Middle East & North Africa (all income levels) to that in North America?
Offer a terse response. 0.73. What is the ratio of the Total Labor Force (in %) of 1990 in Middle East & North Africa (all income levels) to that in OECD members?
Make the answer very short. 0.8. What is the ratio of the Total Labor Force (in %) of 1991 in Middle East & North Africa (all income levels) to that in OECD members?
Your answer should be compact. 0.79. What is the ratio of the Total Labor Force (in %) in 1992 in Middle East & North Africa (all income levels) to that in OECD members?
Your response must be concise. 0.79. What is the ratio of the Total Labor Force (in %) of 1993 in Middle East & North Africa (all income levels) to that in OECD members?
Make the answer very short. 0.79. What is the ratio of the Total Labor Force (in %) in 1990 in Middle East & North Africa (all income levels) to that in Other small states?
Provide a short and direct response. 0.75. What is the ratio of the Total Labor Force (in %) of 1991 in Middle East & North Africa (all income levels) to that in Other small states?
Your response must be concise. 0.74. What is the ratio of the Total Labor Force (in %) in 1992 in Middle East & North Africa (all income levels) to that in Other small states?
Give a very brief answer. 0.74. What is the ratio of the Total Labor Force (in %) in 1993 in Middle East & North Africa (all income levels) to that in Other small states?
Offer a very short reply. 0.74. What is the ratio of the Total Labor Force (in %) in 1990 in Middle East & North Africa (developing only) to that in Middle income?
Make the answer very short. 0.7. What is the ratio of the Total Labor Force (in %) of 1991 in Middle East & North Africa (developing only) to that in Middle income?
Offer a terse response. 0.69. What is the ratio of the Total Labor Force (in %) in 1992 in Middle East & North Africa (developing only) to that in Middle income?
Provide a short and direct response. 0.69. What is the ratio of the Total Labor Force (in %) in 1993 in Middle East & North Africa (developing only) to that in Middle income?
Make the answer very short. 0.69. What is the ratio of the Total Labor Force (in %) of 1990 in Middle East & North Africa (developing only) to that in North America?
Provide a succinct answer. 0.72. What is the ratio of the Total Labor Force (in %) in 1991 in Middle East & North Africa (developing only) to that in North America?
Make the answer very short. 0.71. What is the ratio of the Total Labor Force (in %) of 1992 in Middle East & North Africa (developing only) to that in North America?
Provide a short and direct response. 0.71. What is the ratio of the Total Labor Force (in %) in 1993 in Middle East & North Africa (developing only) to that in North America?
Your answer should be very brief. 0.71. What is the ratio of the Total Labor Force (in %) in 1990 in Middle East & North Africa (developing only) to that in OECD members?
Provide a succinct answer. 0.78. What is the ratio of the Total Labor Force (in %) of 1991 in Middle East & North Africa (developing only) to that in OECD members?
Your answer should be very brief. 0.77. What is the ratio of the Total Labor Force (in %) in 1992 in Middle East & North Africa (developing only) to that in OECD members?
Your answer should be compact. 0.77. What is the ratio of the Total Labor Force (in %) in 1993 in Middle East & North Africa (developing only) to that in OECD members?
Provide a short and direct response. 0.77. What is the ratio of the Total Labor Force (in %) of 1990 in Middle East & North Africa (developing only) to that in Other small states?
Offer a very short reply. 0.73. What is the ratio of the Total Labor Force (in %) of 1991 in Middle East & North Africa (developing only) to that in Other small states?
Your answer should be compact. 0.72. What is the ratio of the Total Labor Force (in %) in 1992 in Middle East & North Africa (developing only) to that in Other small states?
Give a very brief answer. 0.72. What is the ratio of the Total Labor Force (in %) of 1993 in Middle East & North Africa (developing only) to that in Other small states?
Your response must be concise. 0.72. What is the ratio of the Total Labor Force (in %) in 1990 in Middle income to that in North America?
Your answer should be very brief. 1.03. What is the ratio of the Total Labor Force (in %) in 1991 in Middle income to that in North America?
Provide a short and direct response. 1.03. What is the ratio of the Total Labor Force (in %) of 1992 in Middle income to that in North America?
Offer a terse response. 1.03. What is the ratio of the Total Labor Force (in %) in 1993 in Middle income to that in North America?
Your answer should be very brief. 1.03. What is the ratio of the Total Labor Force (in %) of 1990 in Middle income to that in OECD members?
Provide a short and direct response. 1.12. What is the ratio of the Total Labor Force (in %) of 1991 in Middle income to that in OECD members?
Ensure brevity in your answer.  1.12. What is the ratio of the Total Labor Force (in %) of 1992 in Middle income to that in OECD members?
Provide a succinct answer. 1.12. What is the ratio of the Total Labor Force (in %) of 1993 in Middle income to that in OECD members?
Give a very brief answer. 1.12. What is the ratio of the Total Labor Force (in %) in 1990 in Middle income to that in Other small states?
Provide a succinct answer. 1.05. What is the ratio of the Total Labor Force (in %) in 1991 in Middle income to that in Other small states?
Offer a terse response. 1.05. What is the ratio of the Total Labor Force (in %) of 1992 in Middle income to that in Other small states?
Your answer should be very brief. 1.05. What is the ratio of the Total Labor Force (in %) of 1993 in Middle income to that in Other small states?
Keep it short and to the point. 1.05. What is the ratio of the Total Labor Force (in %) of 1990 in North America to that in OECD members?
Your answer should be very brief. 1.09. What is the ratio of the Total Labor Force (in %) in 1991 in North America to that in OECD members?
Give a very brief answer. 1.08. What is the ratio of the Total Labor Force (in %) in 1992 in North America to that in OECD members?
Your answer should be compact. 1.08. What is the ratio of the Total Labor Force (in %) of 1993 in North America to that in OECD members?
Keep it short and to the point. 1.09. What is the ratio of the Total Labor Force (in %) of 1990 in North America to that in Other small states?
Offer a terse response. 1.02. What is the ratio of the Total Labor Force (in %) in 1991 in North America to that in Other small states?
Your answer should be very brief. 1.02. What is the ratio of the Total Labor Force (in %) of 1992 in North America to that in Other small states?
Your answer should be very brief. 1.02. What is the ratio of the Total Labor Force (in %) of 1993 in North America to that in Other small states?
Offer a very short reply. 1.01. What is the ratio of the Total Labor Force (in %) of 1990 in OECD members to that in Other small states?
Ensure brevity in your answer.  0.94. What is the ratio of the Total Labor Force (in %) in 1991 in OECD members to that in Other small states?
Provide a succinct answer. 0.94. What is the ratio of the Total Labor Force (in %) of 1992 in OECD members to that in Other small states?
Give a very brief answer. 0.94. What is the ratio of the Total Labor Force (in %) in 1993 in OECD members to that in Other small states?
Offer a terse response. 0.93. What is the difference between the highest and the second highest Total Labor Force (in %) in 1990?
Provide a short and direct response. 1.86. What is the difference between the highest and the second highest Total Labor Force (in %) in 1991?
Offer a terse response. 2.27. What is the difference between the highest and the second highest Total Labor Force (in %) of 1992?
Your response must be concise. 2.09. What is the difference between the highest and the second highest Total Labor Force (in %) of 1993?
Provide a succinct answer. 2.1. What is the difference between the highest and the lowest Total Labor Force (in %) in 1990?
Provide a short and direct response. 20.43. What is the difference between the highest and the lowest Total Labor Force (in %) in 1991?
Your answer should be very brief. 20.91. What is the difference between the highest and the lowest Total Labor Force (in %) in 1992?
Offer a very short reply. 21.17. What is the difference between the highest and the lowest Total Labor Force (in %) of 1993?
Offer a very short reply. 20.9. 